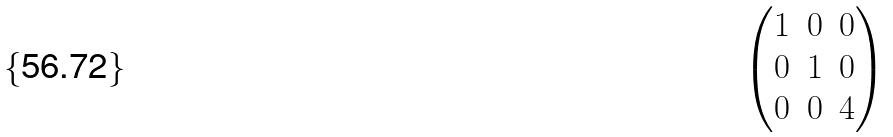Convert formula to latex. <formula><loc_0><loc_0><loc_500><loc_500>\begin{pmatrix} 1 & 0 & 0 \\ 0 & 1 & 0 \\ 0 & 0 & 4 \\ \end{pmatrix}</formula> 